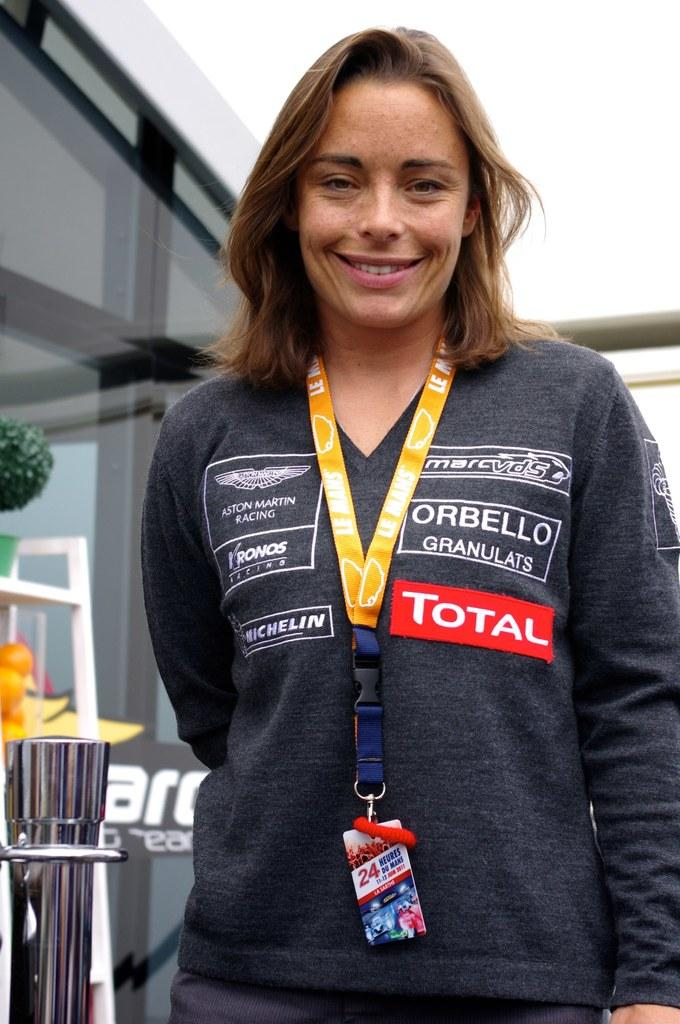Provide a one-sentence caption for the provided image. A woman posing with Total written on her sweater. 